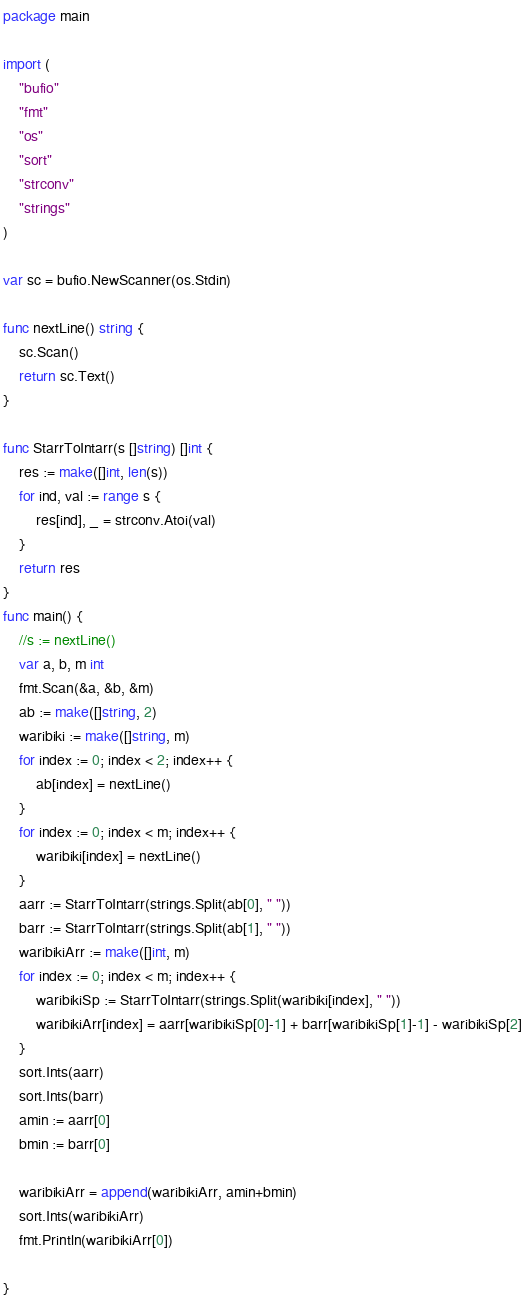<code> <loc_0><loc_0><loc_500><loc_500><_Go_>package main

import (
	"bufio"
	"fmt"
	"os"
	"sort"
	"strconv"
	"strings"
)

var sc = bufio.NewScanner(os.Stdin)

func nextLine() string {
	sc.Scan()
	return sc.Text()
}

func StarrToIntarr(s []string) []int {
	res := make([]int, len(s))
	for ind, val := range s {
		res[ind], _ = strconv.Atoi(val)
	}
	return res
}
func main() {
	//s := nextLine()
	var a, b, m int
	fmt.Scan(&a, &b, &m)
	ab := make([]string, 2)
	waribiki := make([]string, m)
	for index := 0; index < 2; index++ {
		ab[index] = nextLine()
	}
	for index := 0; index < m; index++ {
		waribiki[index] = nextLine()
	}
	aarr := StarrToIntarr(strings.Split(ab[0], " "))
	barr := StarrToIntarr(strings.Split(ab[1], " "))
	waribikiArr := make([]int, m)
	for index := 0; index < m; index++ {
		waribikiSp := StarrToIntarr(strings.Split(waribiki[index], " "))
		waribikiArr[index] = aarr[waribikiSp[0]-1] + barr[waribikiSp[1]-1] - waribikiSp[2]
	}
	sort.Ints(aarr)
	sort.Ints(barr)
	amin := aarr[0]
	bmin := barr[0]

	waribikiArr = append(waribikiArr, amin+bmin)
	sort.Ints(waribikiArr)
	fmt.Println(waribikiArr[0])

}</code> 